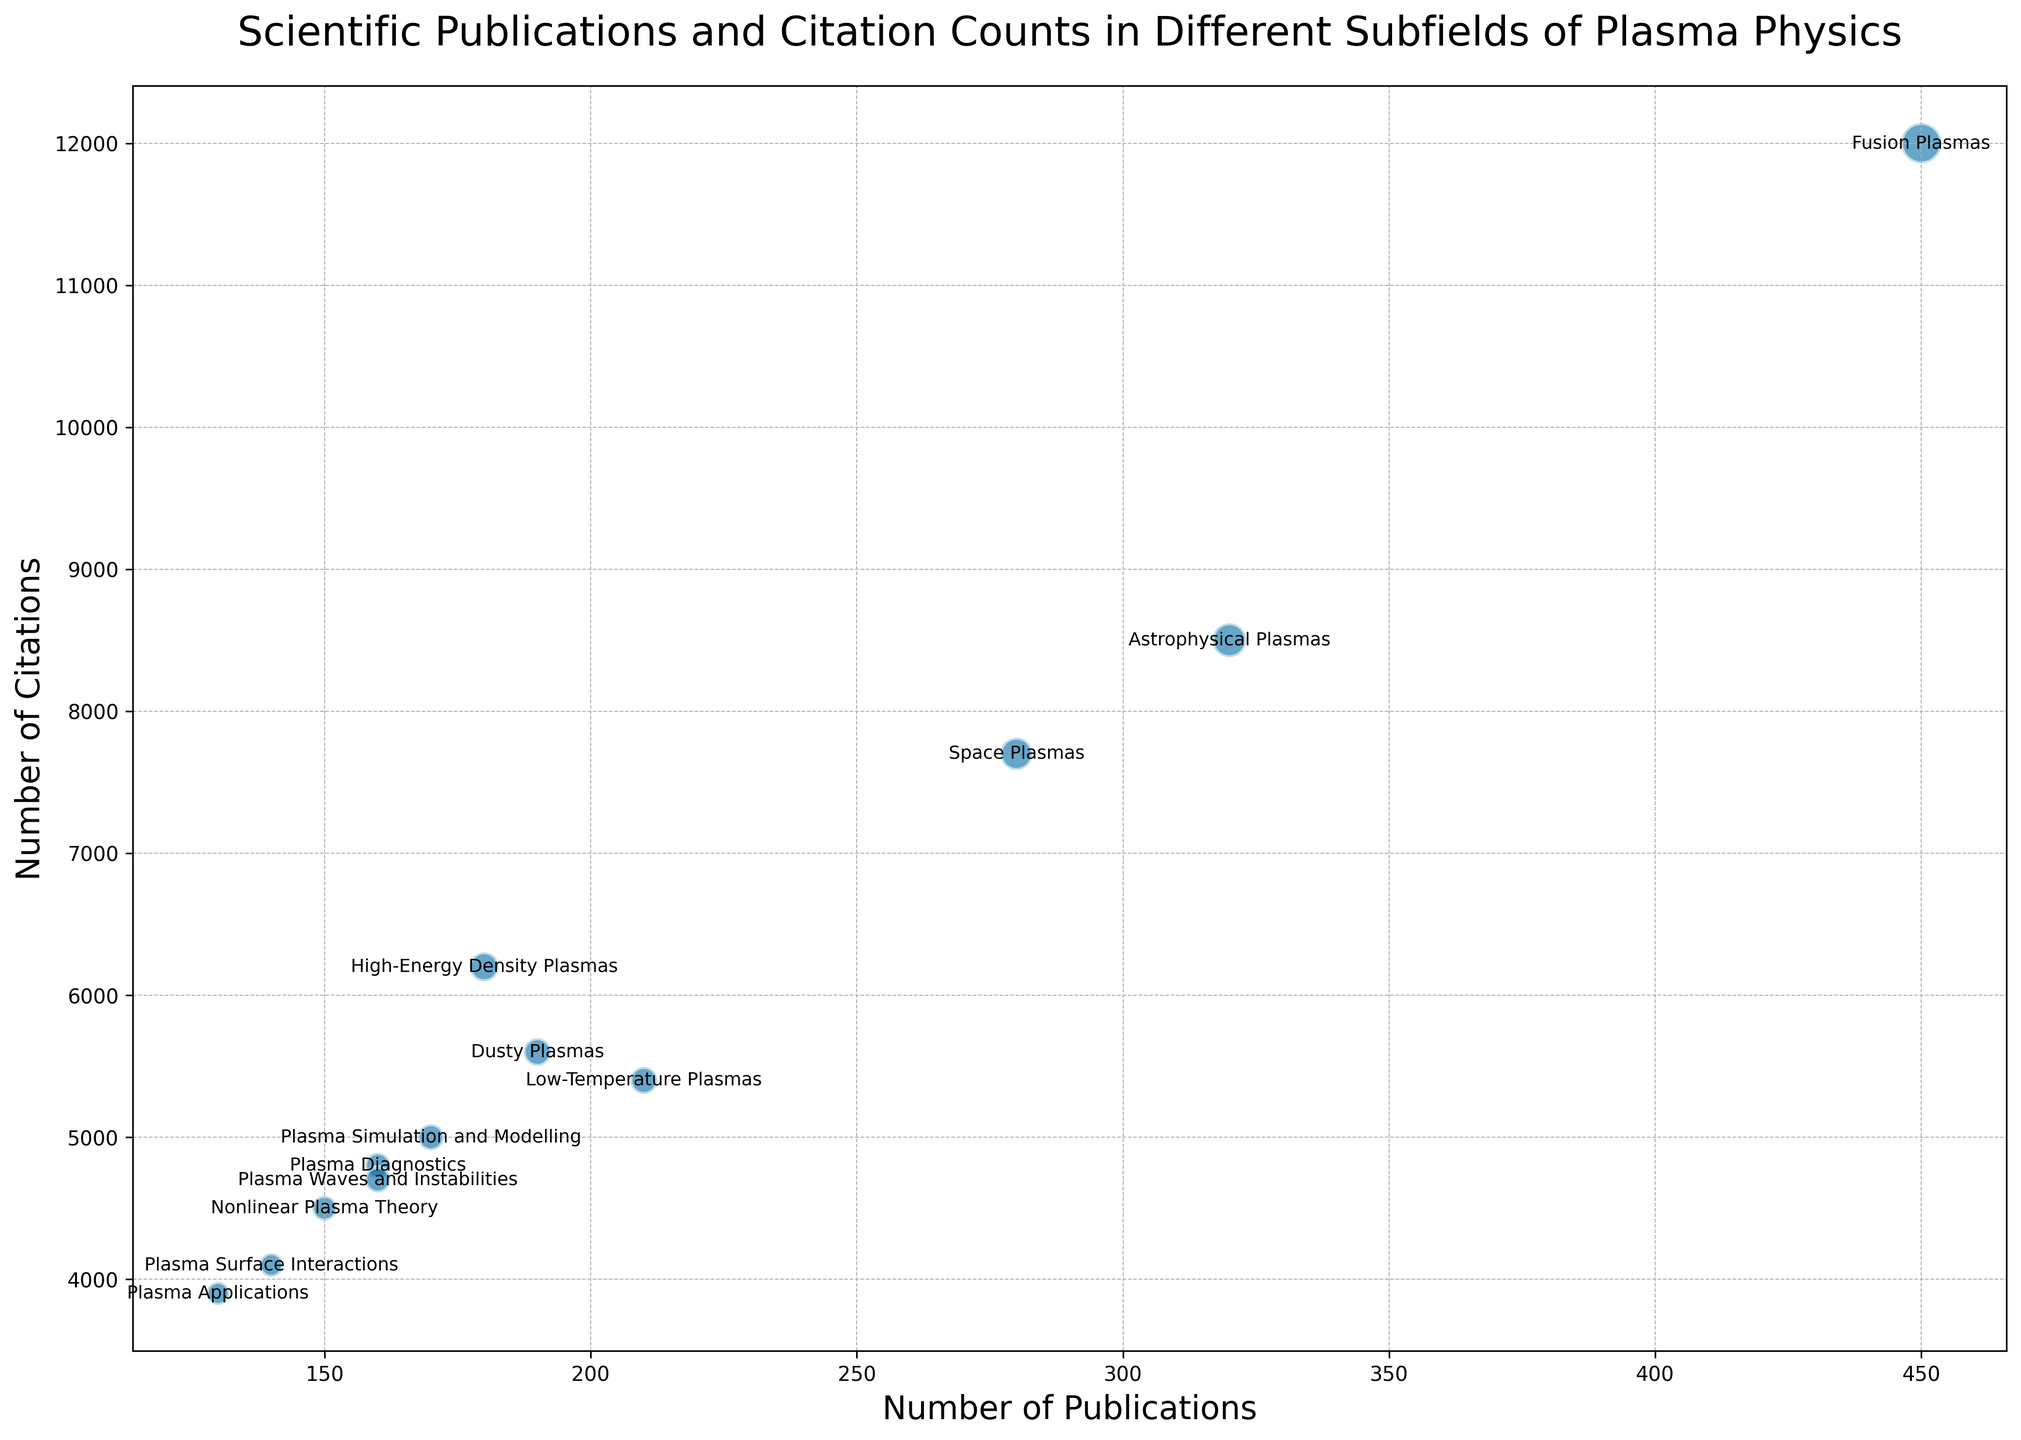How many publications are in the subfield with the highest number of citations? The subfield with the highest number of citations is "Fusion Plasmas" with 12,000 citations. According to the figure, "Fusion Plasmas" has 450 publications.
Answer: 450 Which subfield has the lowest number of citations, and how many publications does it have? The subfield with the lowest number of citations is "Plasma Applications" with 3,900 citations. According to the figure, "Plasma Applications" has 130 publications.
Answer: Plasma Applications, 130 What is the difference in the number of citations between the subfields "Fusion Plasmas" and "Astrophysical Plasmas"? "Fusion Plasmas" has 12,000 citations, and "Astrophysical Plasmas" has 8,500 citations. The difference is 12,000 - 8,500 = 3,500.
Answer: 3,500 Which subfield has more publications, "Plasma Surface Interactions" or "Plasma Waves and Instabilities", and by how many? "Plasma Surface Interactions" has 140 publications, and "Plasma Waves and Instabilities" has 160 publications. "Plasma Waves and Instabilities" has more publications by 160 - 140 = 20.
Answer: Plasma Waves and Instabilities, 20 What is the average number of citations across all subfields? The total number of citations across all subfields is 12000 + 8500 + 7700 + 5400 + 6200 + 5600 + 4800 + 5000 + 4500 + 4100 + 3900 + 4700 = 72,400. There are 12 subfields, so the average is 72,400 / 12 = 6,033.33.
Answer: 6,033.33 How many more citations does "Fusion Plasmas" have compared to "Dusty Plasmas"? "Fusion Plasmas" has 12,000 citations, and "Dusty Plasmas" has 5,600 citations. The difference is 12,000 - 5,600 = 6,400.
Answer: 6,400 In how many subfields is the number of publications greater than 200? The subfields with more than 200 publications are "Fusion Plasmas" (450), "Astrophysical Plasmas" (320), and "Space Plasmas" (280). So, there are 3 subfields with more than 200 publications.
Answer: 3 Which subfield has the smallest bubble size on the chart, and what does it represent? The subfield "Plasma Applications" has the smallest bubble size on the chart, representing the smallest number of citations, which is 3,900.
Answer: Plasma Applications, number of citations What is the total number of publications for the three subfields with the highest number of citations? The subfields with the highest number of citations are "Fusion Plasmas" (12,000), "Astrophysical Plasmas" (8,500), and "Space Plasmas" (7,700). Their total number of publications is 450 + 320 + 280 = 1,050.
Answer: 1,050 